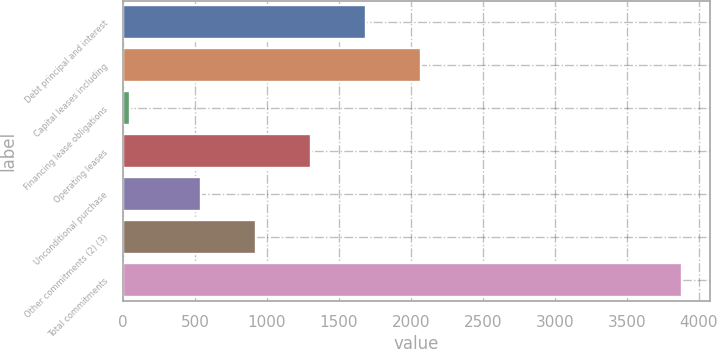Convert chart to OTSL. <chart><loc_0><loc_0><loc_500><loc_500><bar_chart><fcel>Debt principal and interest<fcel>Capital leases including<fcel>Financing lease obligations<fcel>Operating leases<fcel>Unconditional purchase<fcel>Other commitments (2) (3)<fcel>Total commitments<nl><fcel>1689.5<fcel>2073<fcel>49<fcel>1306<fcel>539<fcel>922.5<fcel>3884<nl></chart> 